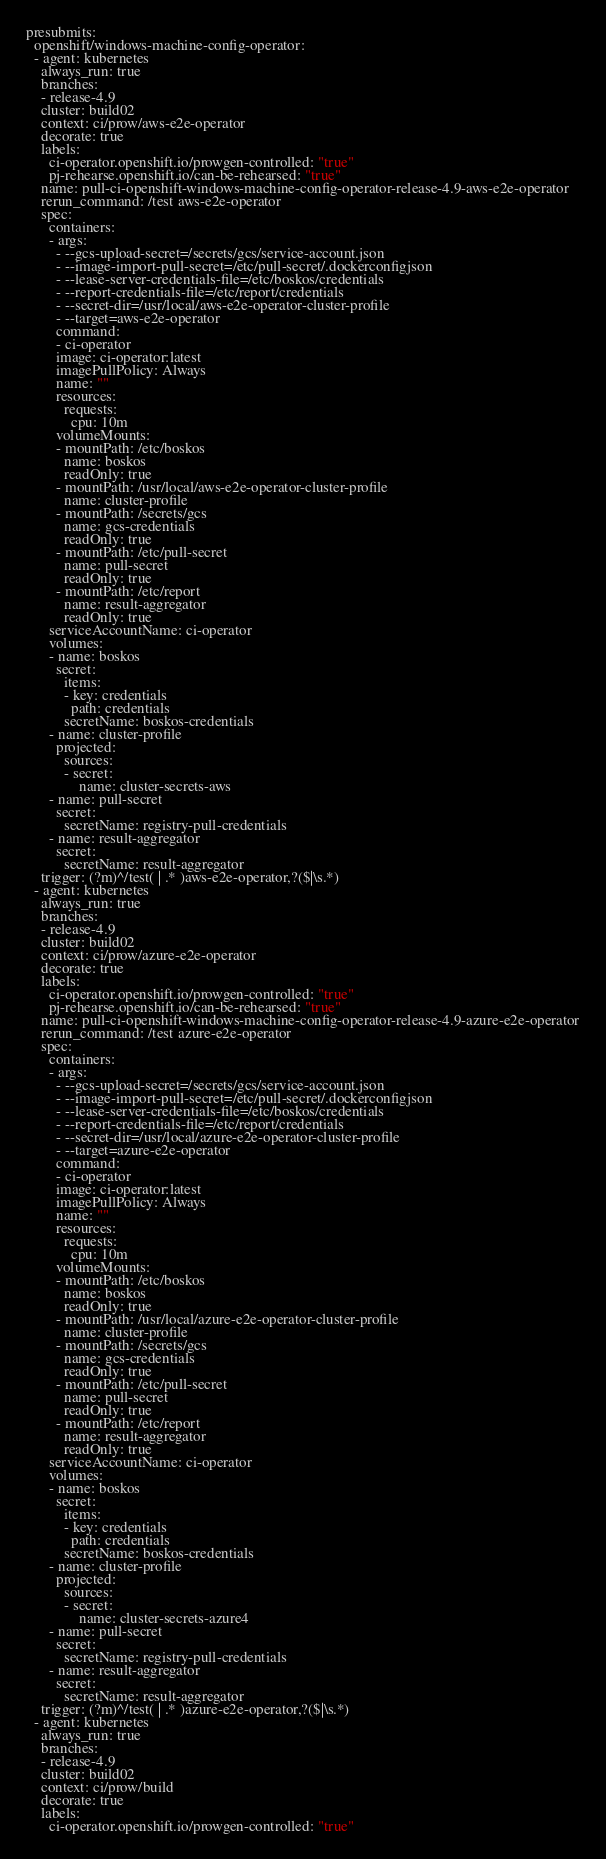<code> <loc_0><loc_0><loc_500><loc_500><_YAML_>presubmits:
  openshift/windows-machine-config-operator:
  - agent: kubernetes
    always_run: true
    branches:
    - release-4.9
    cluster: build02
    context: ci/prow/aws-e2e-operator
    decorate: true
    labels:
      ci-operator.openshift.io/prowgen-controlled: "true"
      pj-rehearse.openshift.io/can-be-rehearsed: "true"
    name: pull-ci-openshift-windows-machine-config-operator-release-4.9-aws-e2e-operator
    rerun_command: /test aws-e2e-operator
    spec:
      containers:
      - args:
        - --gcs-upload-secret=/secrets/gcs/service-account.json
        - --image-import-pull-secret=/etc/pull-secret/.dockerconfigjson
        - --lease-server-credentials-file=/etc/boskos/credentials
        - --report-credentials-file=/etc/report/credentials
        - --secret-dir=/usr/local/aws-e2e-operator-cluster-profile
        - --target=aws-e2e-operator
        command:
        - ci-operator
        image: ci-operator:latest
        imagePullPolicy: Always
        name: ""
        resources:
          requests:
            cpu: 10m
        volumeMounts:
        - mountPath: /etc/boskos
          name: boskos
          readOnly: true
        - mountPath: /usr/local/aws-e2e-operator-cluster-profile
          name: cluster-profile
        - mountPath: /secrets/gcs
          name: gcs-credentials
          readOnly: true
        - mountPath: /etc/pull-secret
          name: pull-secret
          readOnly: true
        - mountPath: /etc/report
          name: result-aggregator
          readOnly: true
      serviceAccountName: ci-operator
      volumes:
      - name: boskos
        secret:
          items:
          - key: credentials
            path: credentials
          secretName: boskos-credentials
      - name: cluster-profile
        projected:
          sources:
          - secret:
              name: cluster-secrets-aws
      - name: pull-secret
        secret:
          secretName: registry-pull-credentials
      - name: result-aggregator
        secret:
          secretName: result-aggregator
    trigger: (?m)^/test( | .* )aws-e2e-operator,?($|\s.*)
  - agent: kubernetes
    always_run: true
    branches:
    - release-4.9
    cluster: build02
    context: ci/prow/azure-e2e-operator
    decorate: true
    labels:
      ci-operator.openshift.io/prowgen-controlled: "true"
      pj-rehearse.openshift.io/can-be-rehearsed: "true"
    name: pull-ci-openshift-windows-machine-config-operator-release-4.9-azure-e2e-operator
    rerun_command: /test azure-e2e-operator
    spec:
      containers:
      - args:
        - --gcs-upload-secret=/secrets/gcs/service-account.json
        - --image-import-pull-secret=/etc/pull-secret/.dockerconfigjson
        - --lease-server-credentials-file=/etc/boskos/credentials
        - --report-credentials-file=/etc/report/credentials
        - --secret-dir=/usr/local/azure-e2e-operator-cluster-profile
        - --target=azure-e2e-operator
        command:
        - ci-operator
        image: ci-operator:latest
        imagePullPolicy: Always
        name: ""
        resources:
          requests:
            cpu: 10m
        volumeMounts:
        - mountPath: /etc/boskos
          name: boskos
          readOnly: true
        - mountPath: /usr/local/azure-e2e-operator-cluster-profile
          name: cluster-profile
        - mountPath: /secrets/gcs
          name: gcs-credentials
          readOnly: true
        - mountPath: /etc/pull-secret
          name: pull-secret
          readOnly: true
        - mountPath: /etc/report
          name: result-aggregator
          readOnly: true
      serviceAccountName: ci-operator
      volumes:
      - name: boskos
        secret:
          items:
          - key: credentials
            path: credentials
          secretName: boskos-credentials
      - name: cluster-profile
        projected:
          sources:
          - secret:
              name: cluster-secrets-azure4
      - name: pull-secret
        secret:
          secretName: registry-pull-credentials
      - name: result-aggregator
        secret:
          secretName: result-aggregator
    trigger: (?m)^/test( | .* )azure-e2e-operator,?($|\s.*)
  - agent: kubernetes
    always_run: true
    branches:
    - release-4.9
    cluster: build02
    context: ci/prow/build
    decorate: true
    labels:
      ci-operator.openshift.io/prowgen-controlled: "true"</code> 